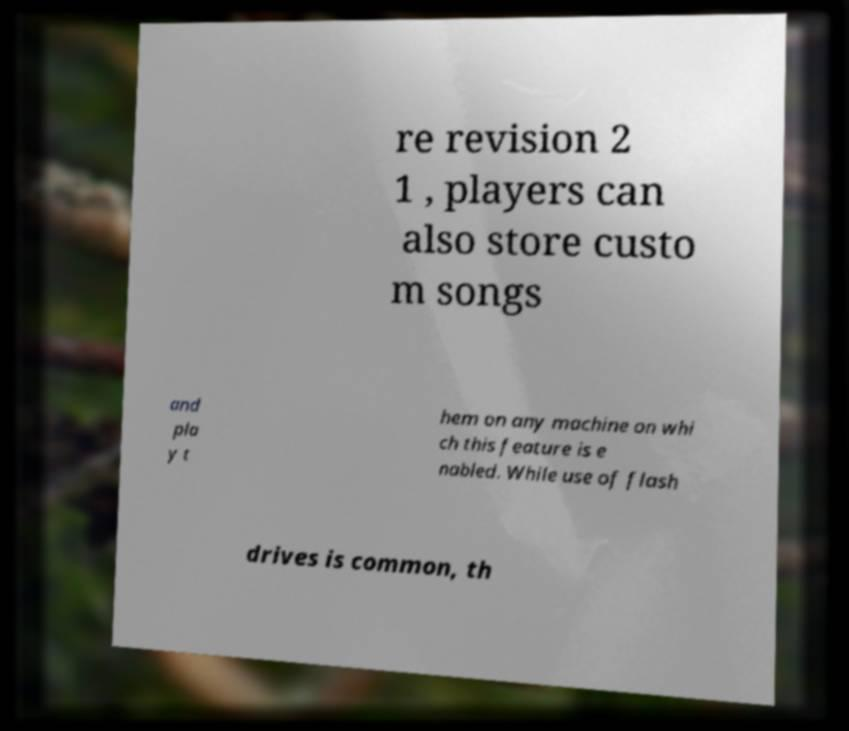Please identify and transcribe the text found in this image. re revision 2 1 , players can also store custo m songs and pla y t hem on any machine on whi ch this feature is e nabled. While use of flash drives is common, th 